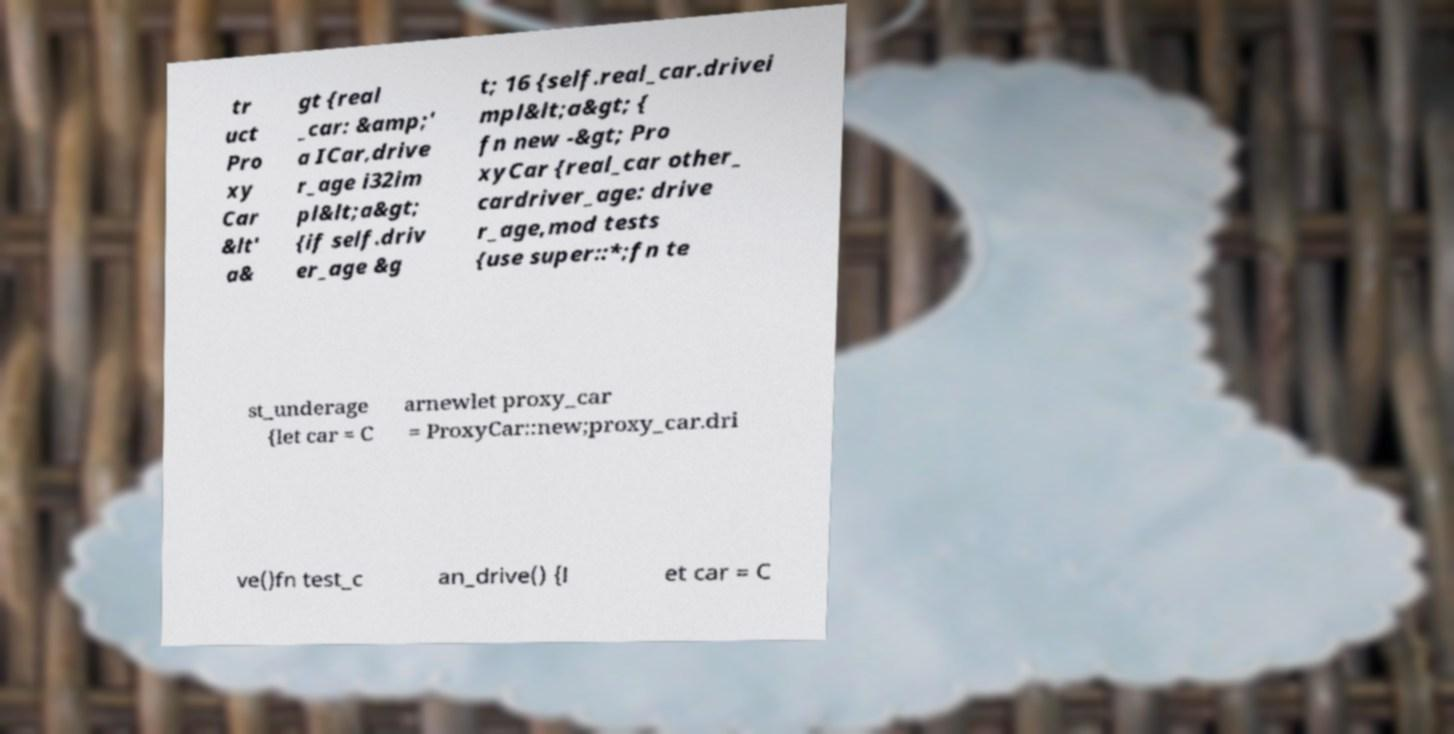Please read and relay the text visible in this image. What does it say? tr uct Pro xy Car &lt' a& gt {real _car: &amp;' a ICar,drive r_age i32im pl&lt;a&gt; {if self.driv er_age &g t; 16 {self.real_car.drivei mpl&lt;a&gt; { fn new -&gt; Pro xyCar {real_car other_ cardriver_age: drive r_age,mod tests {use super::*;fn te st_underage {let car = C arnewlet proxy_car = ProxyCar::new;proxy_car.dri ve()fn test_c an_drive() {l et car = C 